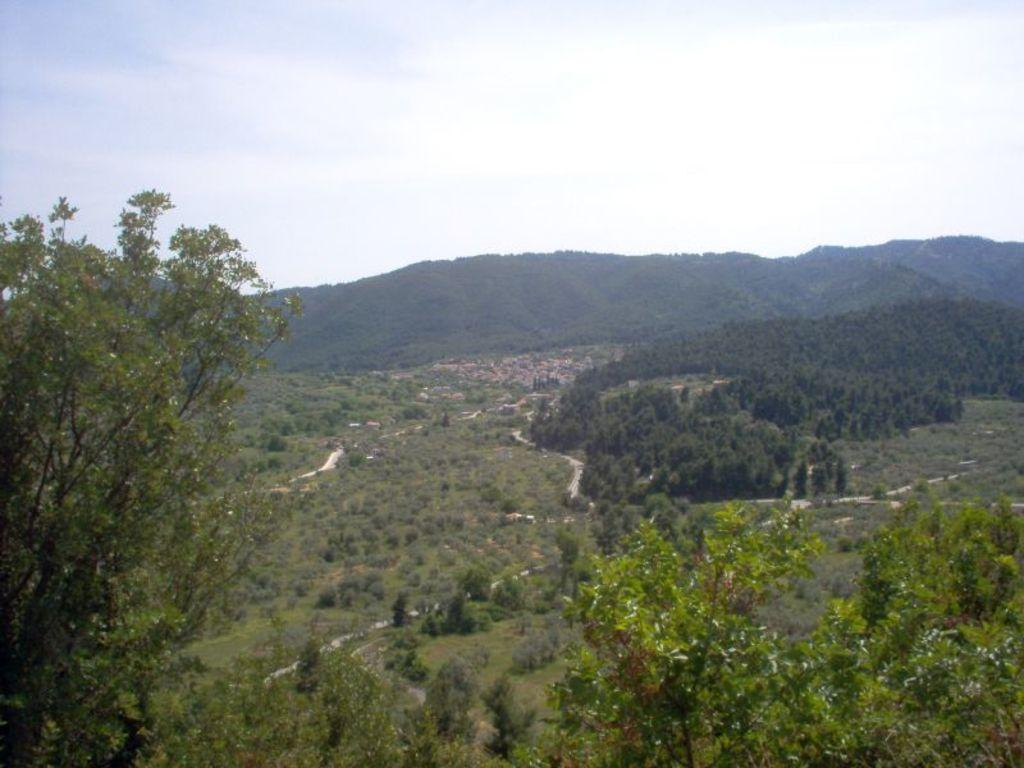What type of vegetation can be seen in the image? There are trees and grass in the image. What type of natural landform is visible in the image? There are mountains in the image. What is visible at the top of the image? The sky is visible at the top of the image. What might be the location where the image was taken? The image may have been taken in a forest, given the presence of trees. What type of prison can be seen in the image? There is no prison present in the image. What is the cork used for in the image? There is no cork present in the image. 